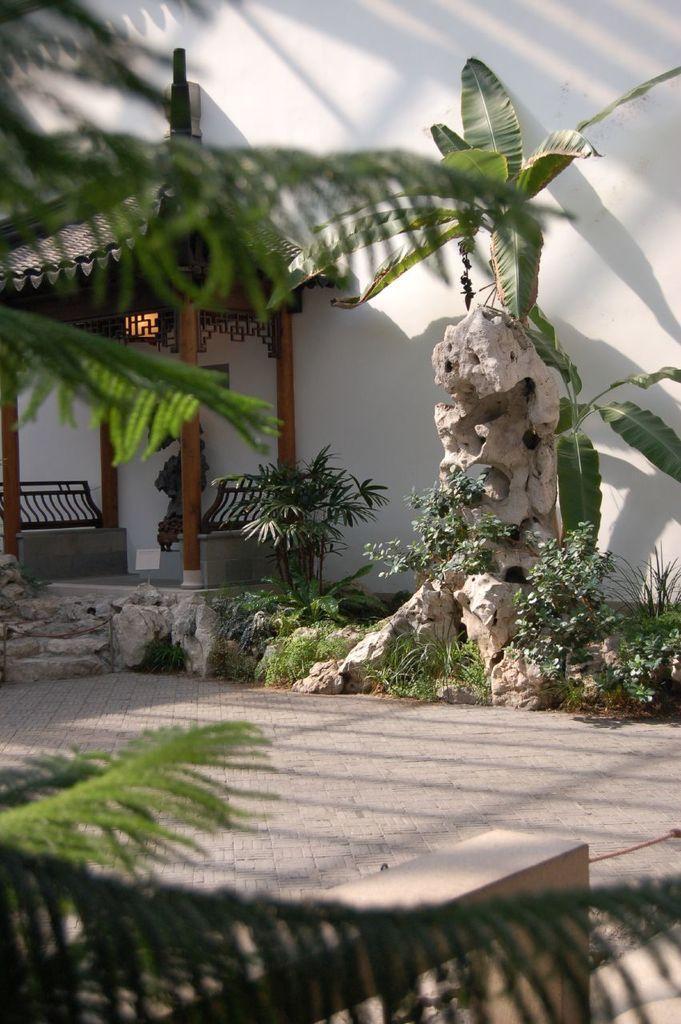Can you describe this image briefly? This picture shows a wall and we see trees and few plants and small hut. We see two benches in it. 